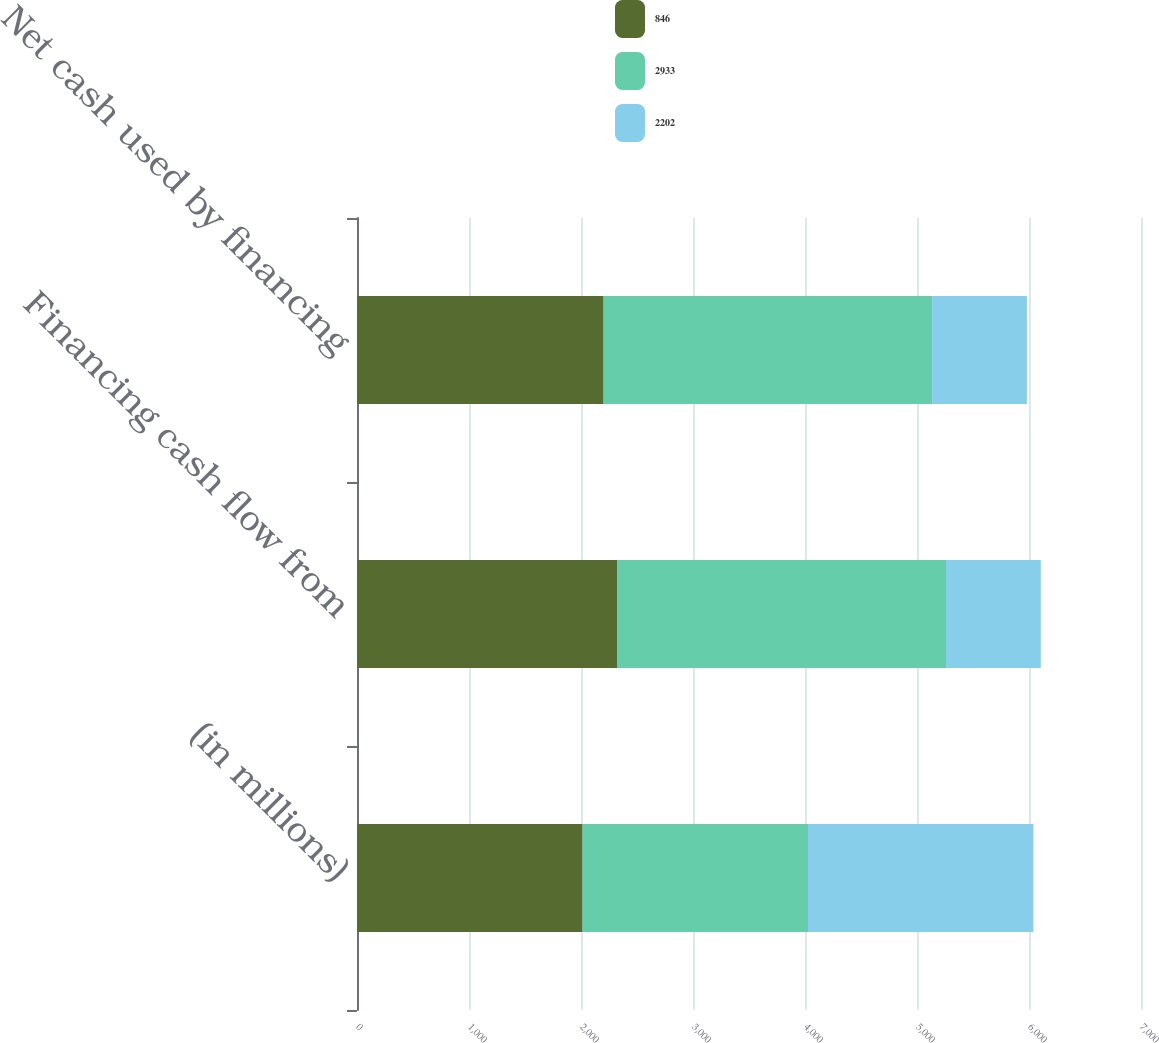Convert chart. <chart><loc_0><loc_0><loc_500><loc_500><stacked_bar_chart><ecel><fcel>(in millions)<fcel>Financing cash flow from<fcel>Net cash used by financing<nl><fcel>846<fcel>2014<fcel>2326<fcel>2202<nl><fcel>2933<fcel>2013<fcel>2933<fcel>2933<nl><fcel>2202<fcel>2012<fcel>846<fcel>846<nl></chart> 